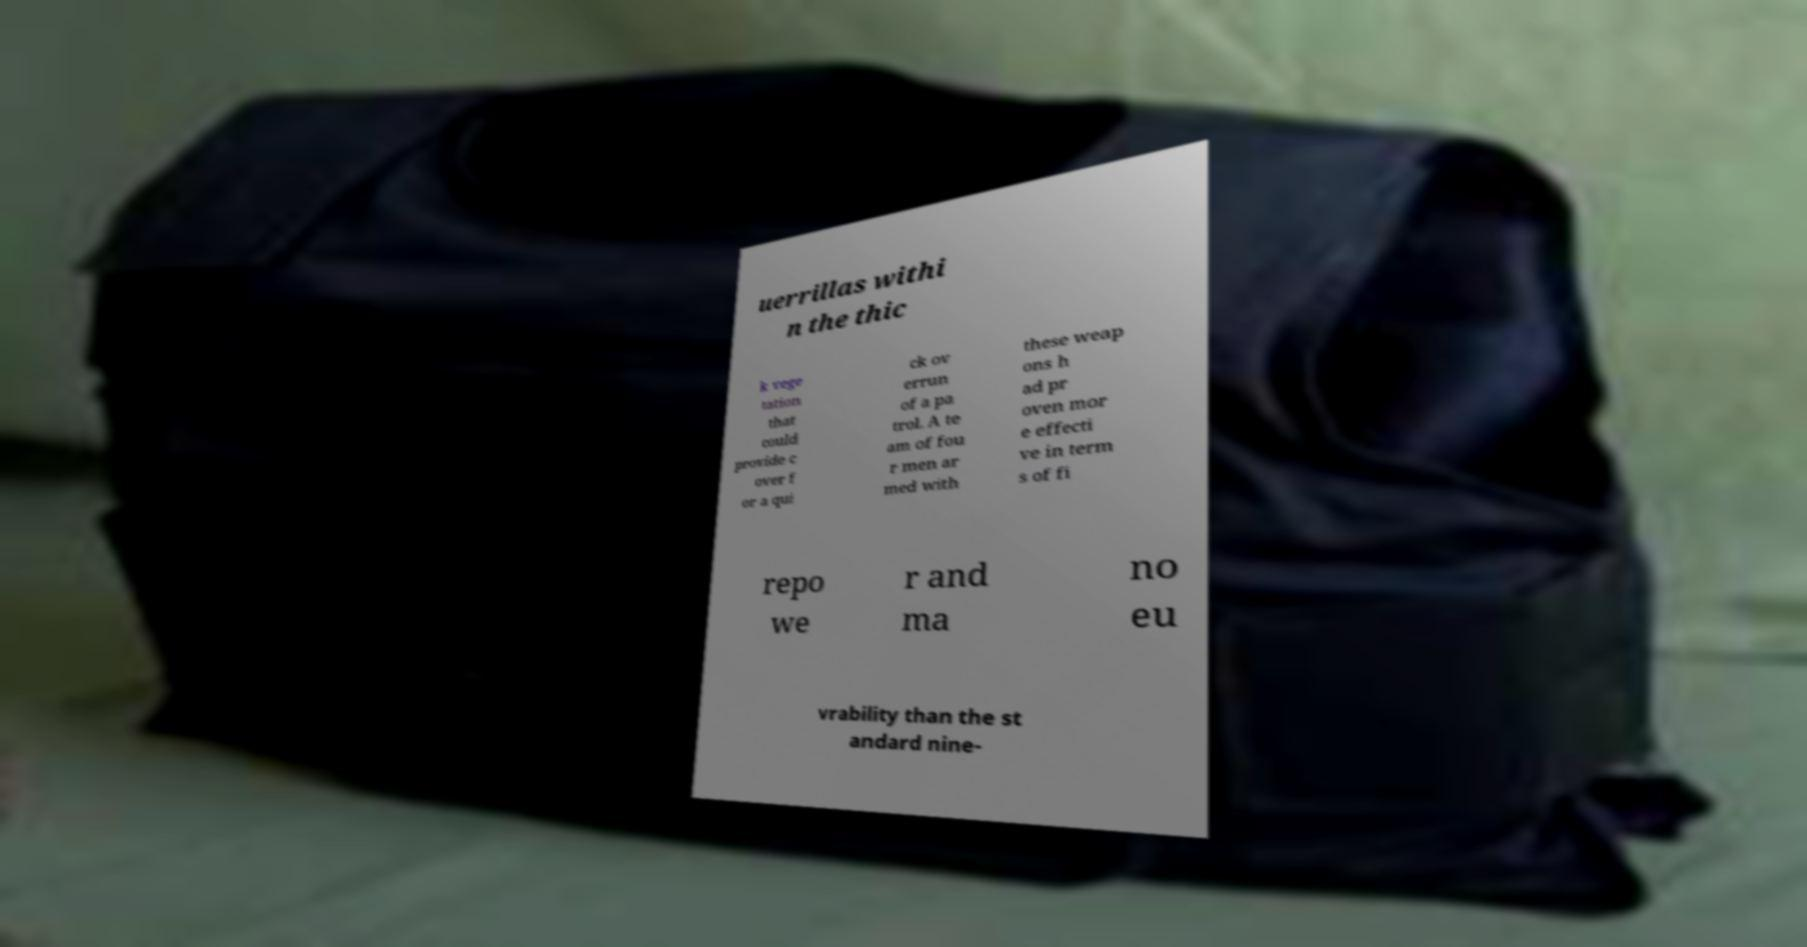Could you extract and type out the text from this image? uerrillas withi n the thic k vege tation that could provide c over f or a qui ck ov errun of a pa trol. A te am of fou r men ar med with these weap ons h ad pr oven mor e effecti ve in term s of fi repo we r and ma no eu vrability than the st andard nine- 